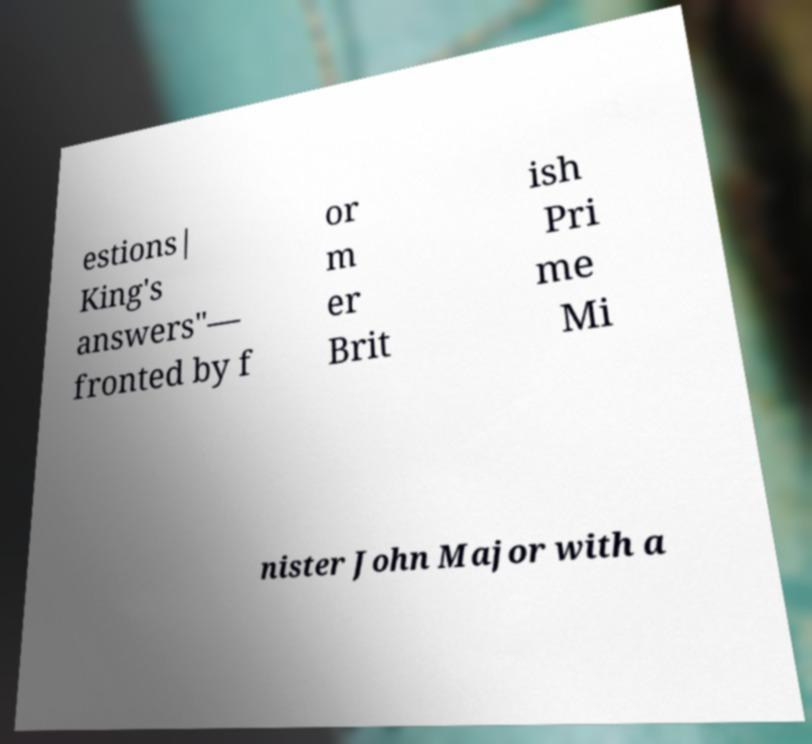For documentation purposes, I need the text within this image transcribed. Could you provide that? estions| King's answers"— fronted by f or m er Brit ish Pri me Mi nister John Major with a 